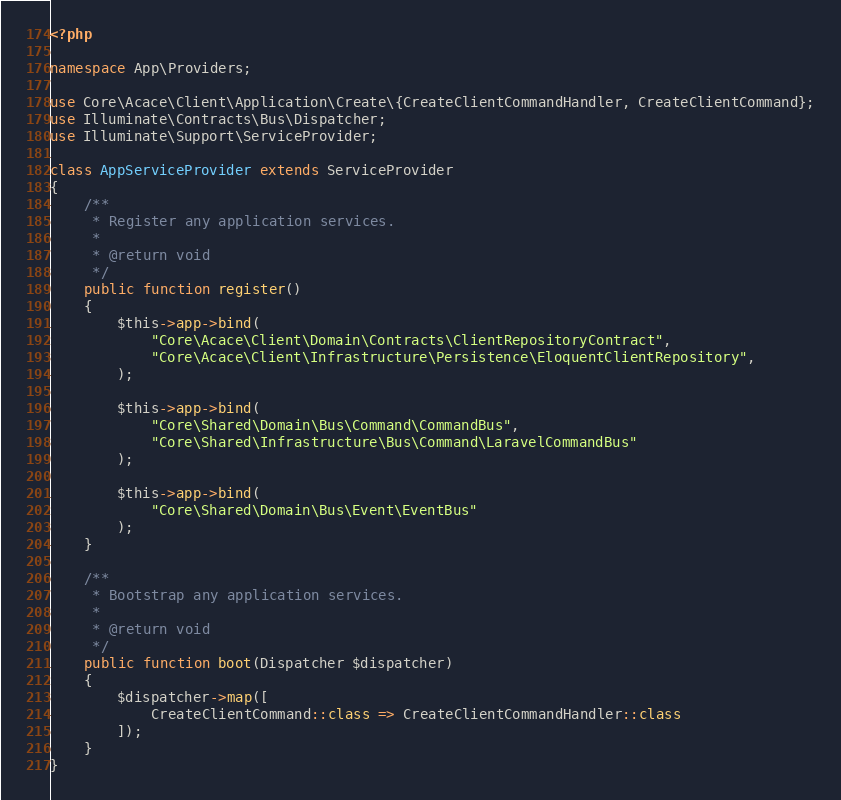<code> <loc_0><loc_0><loc_500><loc_500><_PHP_><?php

namespace App\Providers;

use Core\Acace\Client\Application\Create\{CreateClientCommandHandler, CreateClientCommand};
use Illuminate\Contracts\Bus\Dispatcher;
use Illuminate\Support\ServiceProvider;

class AppServiceProvider extends ServiceProvider
{
    /**
     * Register any application services.
     *
     * @return void
     */
    public function register()
    {
        $this->app->bind(
            "Core\Acace\Client\Domain\Contracts\ClientRepositoryContract",
            "Core\Acace\Client\Infrastructure\Persistence\EloquentClientRepository",
        );

        $this->app->bind(
            "Core\Shared\Domain\Bus\Command\CommandBus",
            "Core\Shared\Infrastructure\Bus\Command\LaravelCommandBus"
        );

        $this->app->bind(
            "Core\Shared\Domain\Bus\Event\EventBus"
        );
    }

    /**
     * Bootstrap any application services.
     *
     * @return void
     */
    public function boot(Dispatcher $dispatcher)
    {
        $dispatcher->map([
            CreateClientCommand::class => CreateClientCommandHandler::class
        ]);
    }
}
</code> 